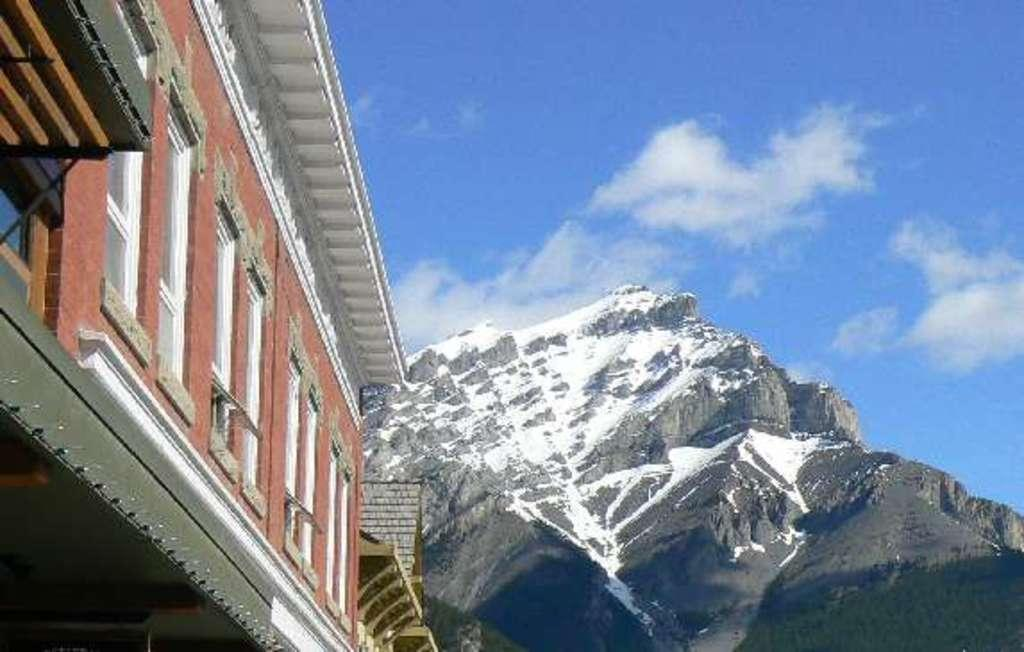What type of structure is in the image? There is a building in the image. What feature can be seen on the building? The building has windows. What natural element is present in the image? There is a rock in the image. What can be seen in the background of the image? The sky is visible in the background of the image. What atmospheric conditions are present in the sky? Clouds are present in the sky. How many bridges can be seen crossing the street in the image? There is no street or bridge present in the image. 